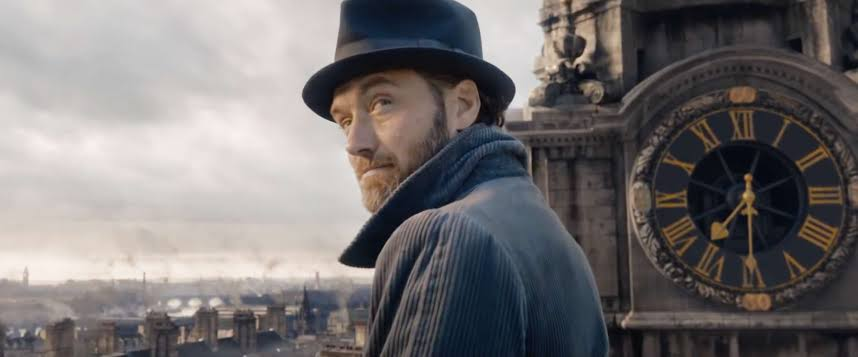Can you describe the architectural style visible in the background? The architecture shown in the image features grand, detailed structures and a large clock face, indicative of neoclassical or Gothic Revival styles. These designs are often associated with significant public buildings or landmarks from the 18th or 19th century, illustrating an emphasis on grandeur and historical reference. 